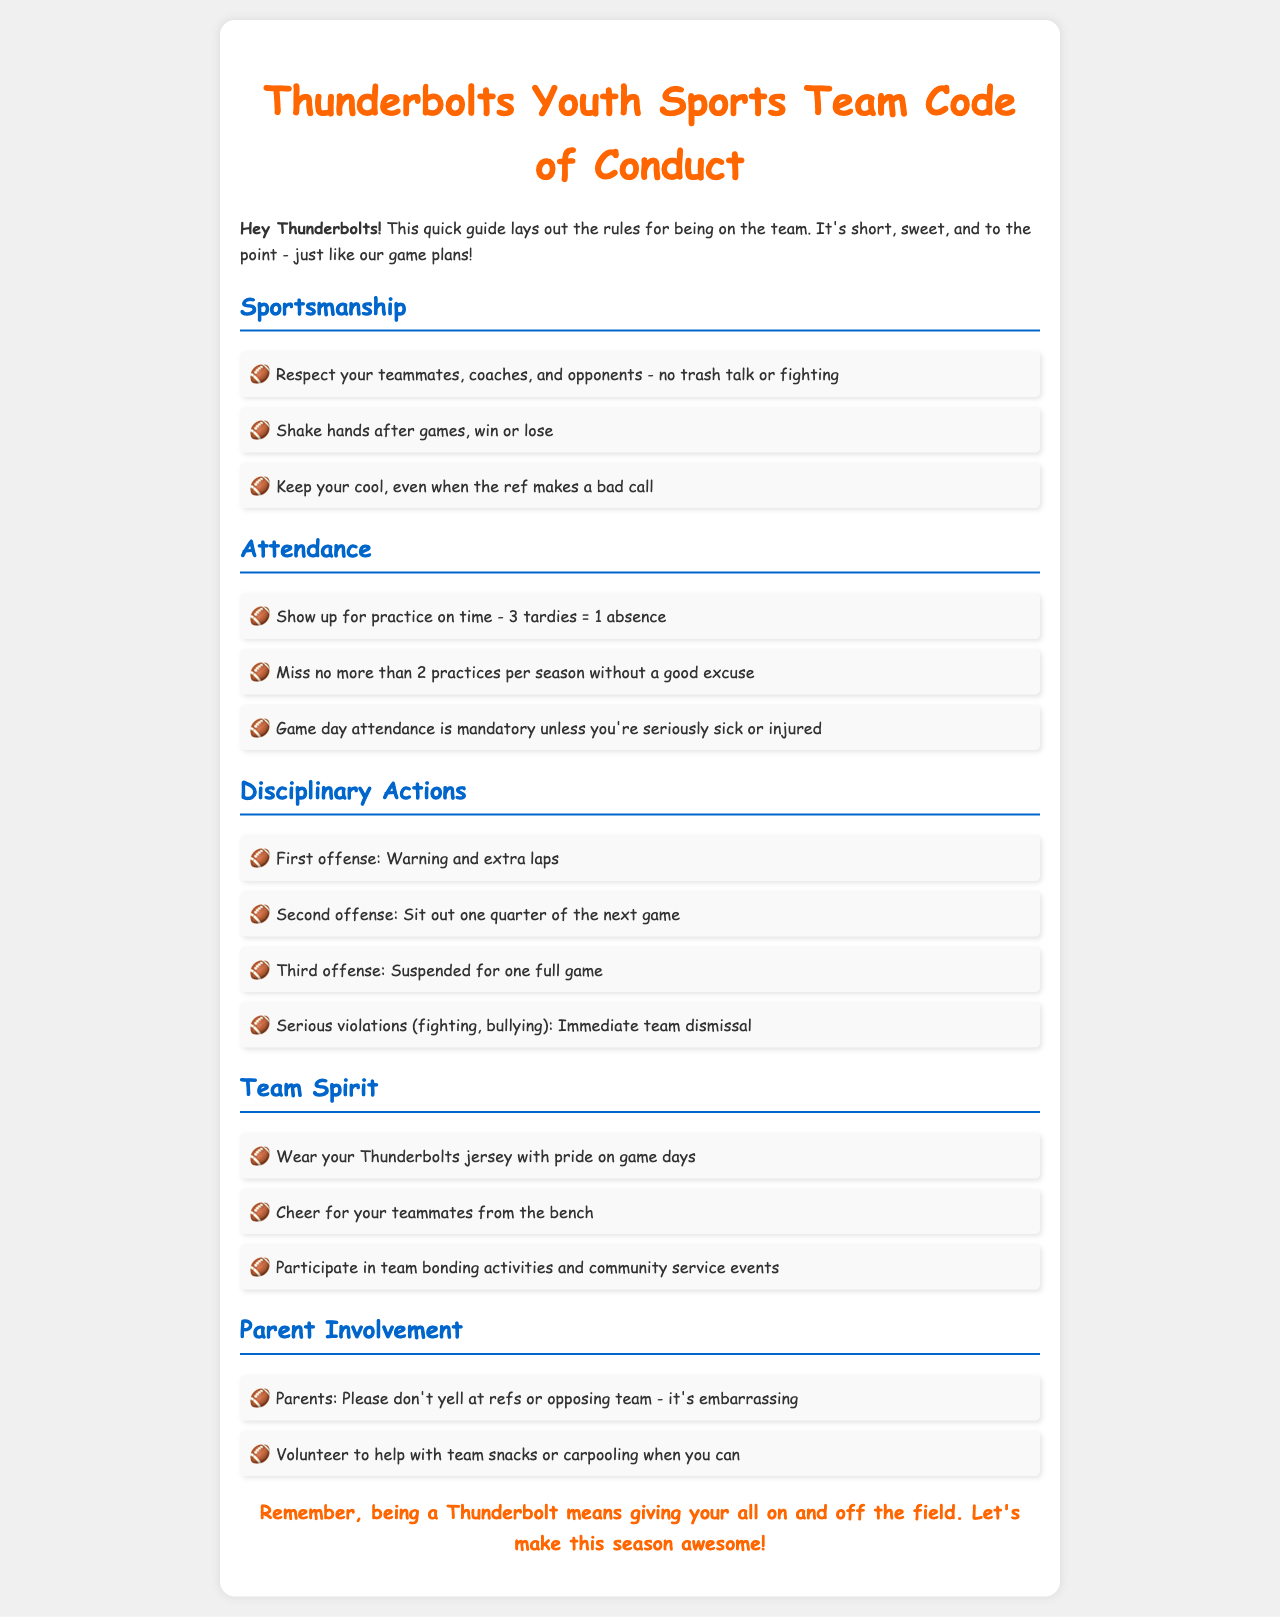what is the code of conduct called? The document refers to the rules as the "Thunderbolts Youth Sports Team Code of Conduct."
Answer: Thunderbolts Youth Sports Team Code of Conduct how many tardies equal one absence? The document states "3 tardies = 1 absence."
Answer: 3 what happens on the first offense of a rule violation? The document specifies that the first offense results in a "Warning and extra laps."
Answer: Warning and extra laps how many practices can you miss without a good excuse? According to the attendance section, you can miss "no more than 2 practices per season without a good excuse."
Answer: 2 practices what must you do after games regardless of the outcome? The rules require players to "Shake hands after games, win or lose."
Answer: Shake hands what is the consequence for serious violations like fighting? The document states that serious violations result in "Immediate team dismissal."
Answer: Immediate team dismissal how many quarters do you sit out for a second offense? For the second offense, the player must "Sit out one quarter of the next game."
Answer: One quarter what must parents avoid doing during games? Parents are advised to "Please don't yell at refs or opposing team - it's embarrassing."
Answer: Yell at refs what is one of the requirements for game day attendance? The document specifies that game day attendance is "mandatory unless you're seriously sick or injured."
Answer: Mandatory 